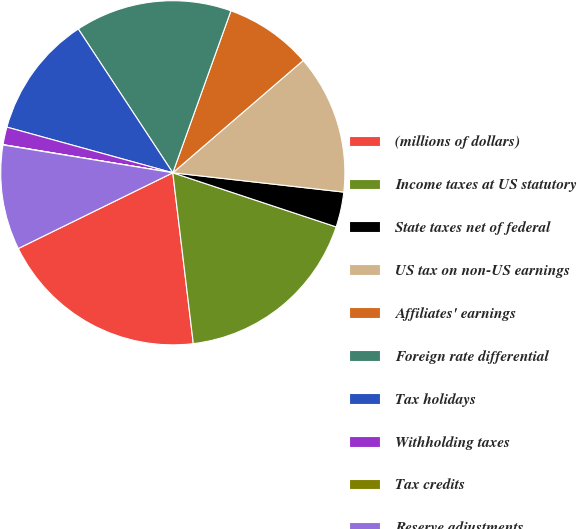Convert chart. <chart><loc_0><loc_0><loc_500><loc_500><pie_chart><fcel>(millions of dollars)<fcel>Income taxes at US statutory<fcel>State taxes net of federal<fcel>US tax on non-US earnings<fcel>Affiliates' earnings<fcel>Foreign rate differential<fcel>Tax holidays<fcel>Withholding taxes<fcel>Tax credits<fcel>Reserve adjustments<nl><fcel>19.65%<fcel>18.01%<fcel>3.3%<fcel>13.11%<fcel>8.2%<fcel>14.74%<fcel>11.47%<fcel>1.66%<fcel>0.03%<fcel>9.84%<nl></chart> 